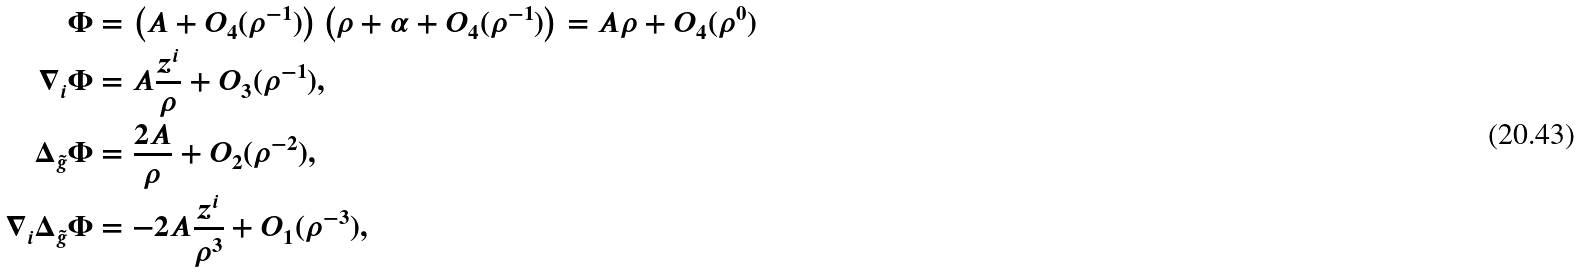Convert formula to latex. <formula><loc_0><loc_0><loc_500><loc_500>\Phi & = \left ( A + O _ { 4 } ( \rho ^ { - 1 } ) \right ) \left ( \rho + \alpha + O _ { 4 } ( \rho ^ { - 1 } ) \right ) = A \rho + O _ { 4 } ( \rho ^ { 0 } ) \\ \nabla _ { i } \Phi & = A \frac { z ^ { i } } { \rho } + O _ { 3 } ( \rho ^ { - 1 } ) , \\ \Delta _ { \tilde { g } } \Phi & = \frac { 2 A } { \rho } + O _ { 2 } ( \rho ^ { - 2 } ) , \\ \nabla _ { i } \Delta _ { \tilde { g } } \Phi & = - 2 A \frac { z ^ { i } } { \rho ^ { 3 } } + O _ { 1 } ( \rho ^ { - 3 } ) ,</formula> 